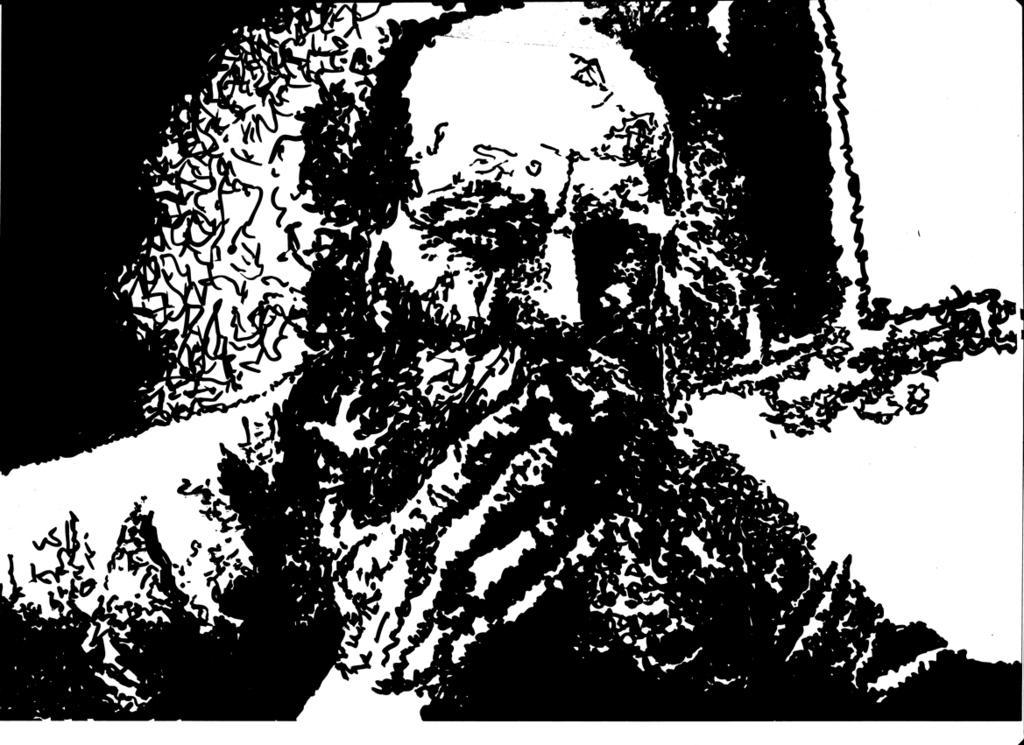In one or two sentences, can you explain what this image depicts? I can see an edited picture in which I can see a person. 